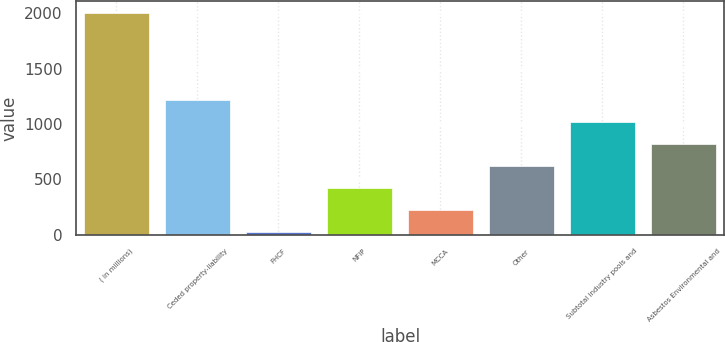<chart> <loc_0><loc_0><loc_500><loc_500><bar_chart><fcel>( in millions)<fcel>Ceded property-liability<fcel>FHCF<fcel>NFIP<fcel>MCCA<fcel>Other<fcel>Subtotal industry pools and<fcel>Asbestos Environmental and<nl><fcel>2007<fcel>1213<fcel>22<fcel>419<fcel>220.5<fcel>617.5<fcel>1014.5<fcel>816<nl></chart> 